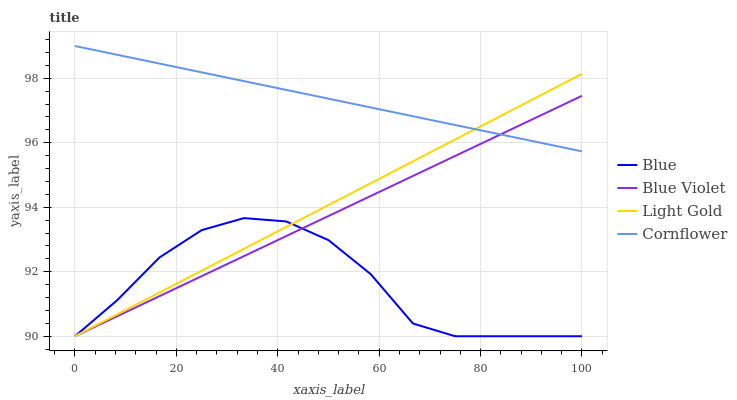Does Blue have the minimum area under the curve?
Answer yes or no. Yes. Does Cornflower have the maximum area under the curve?
Answer yes or no. Yes. Does Light Gold have the minimum area under the curve?
Answer yes or no. No. Does Light Gold have the maximum area under the curve?
Answer yes or no. No. Is Blue Violet the smoothest?
Answer yes or no. Yes. Is Blue the roughest?
Answer yes or no. Yes. Is Cornflower the smoothest?
Answer yes or no. No. Is Cornflower the roughest?
Answer yes or no. No. Does Cornflower have the lowest value?
Answer yes or no. No. Does Cornflower have the highest value?
Answer yes or no. Yes. Does Light Gold have the highest value?
Answer yes or no. No. Is Blue less than Cornflower?
Answer yes or no. Yes. Is Cornflower greater than Blue?
Answer yes or no. Yes. Does Cornflower intersect Blue Violet?
Answer yes or no. Yes. Is Cornflower less than Blue Violet?
Answer yes or no. No. Is Cornflower greater than Blue Violet?
Answer yes or no. No. Does Blue intersect Cornflower?
Answer yes or no. No. 